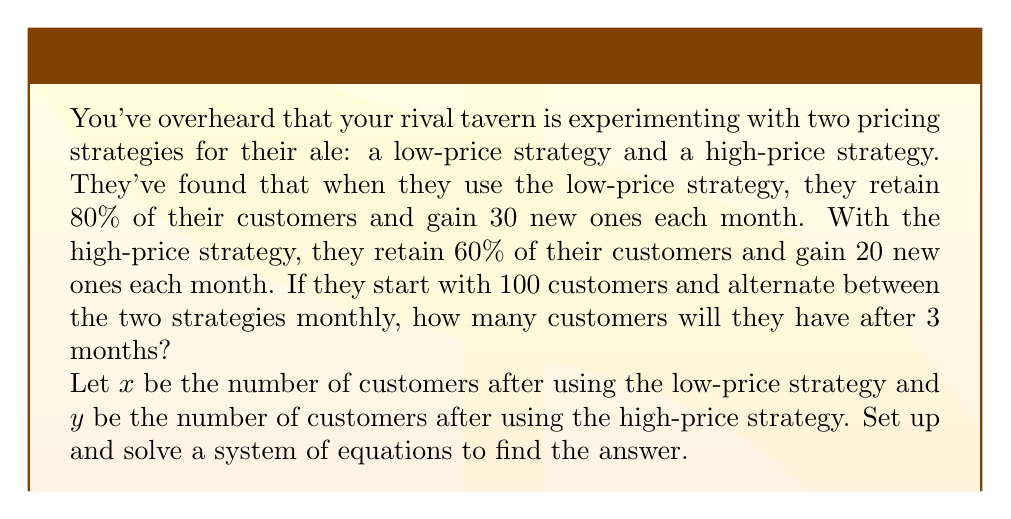Give your solution to this math problem. Let's approach this step-by-step:

1) First, let's set up our equations based on the given information:

   For the low-price strategy: $x = 0.8y + 30$
   For the high-price strategy: $y = 0.6x + 20$

2) We start with 100 customers and use the high-price strategy first, then low-price, then high-price again. So we need to solve this system of equations twice.

3) Let's substitute the second equation into the first:

   $x = 0.8(0.6x + 20) + 30$
   $x = 0.48x + 16 + 30$
   $x = 0.48x + 46$
   $0.52x = 46$
   $x = 88.46$

4) Now we can find $y$:

   $y = 0.6(88.46) + 20 = 73.08$

5) So after two months (high-price then low-price), they have 88.46 customers.

6) For the third month (high-price again), we calculate:

   $y = 0.6(88.46) + 20 = 73.08$

Therefore, after 3 months, the rival tavern will have approximately 73 customers.
Answer: 73 customers (rounded to the nearest whole number) 